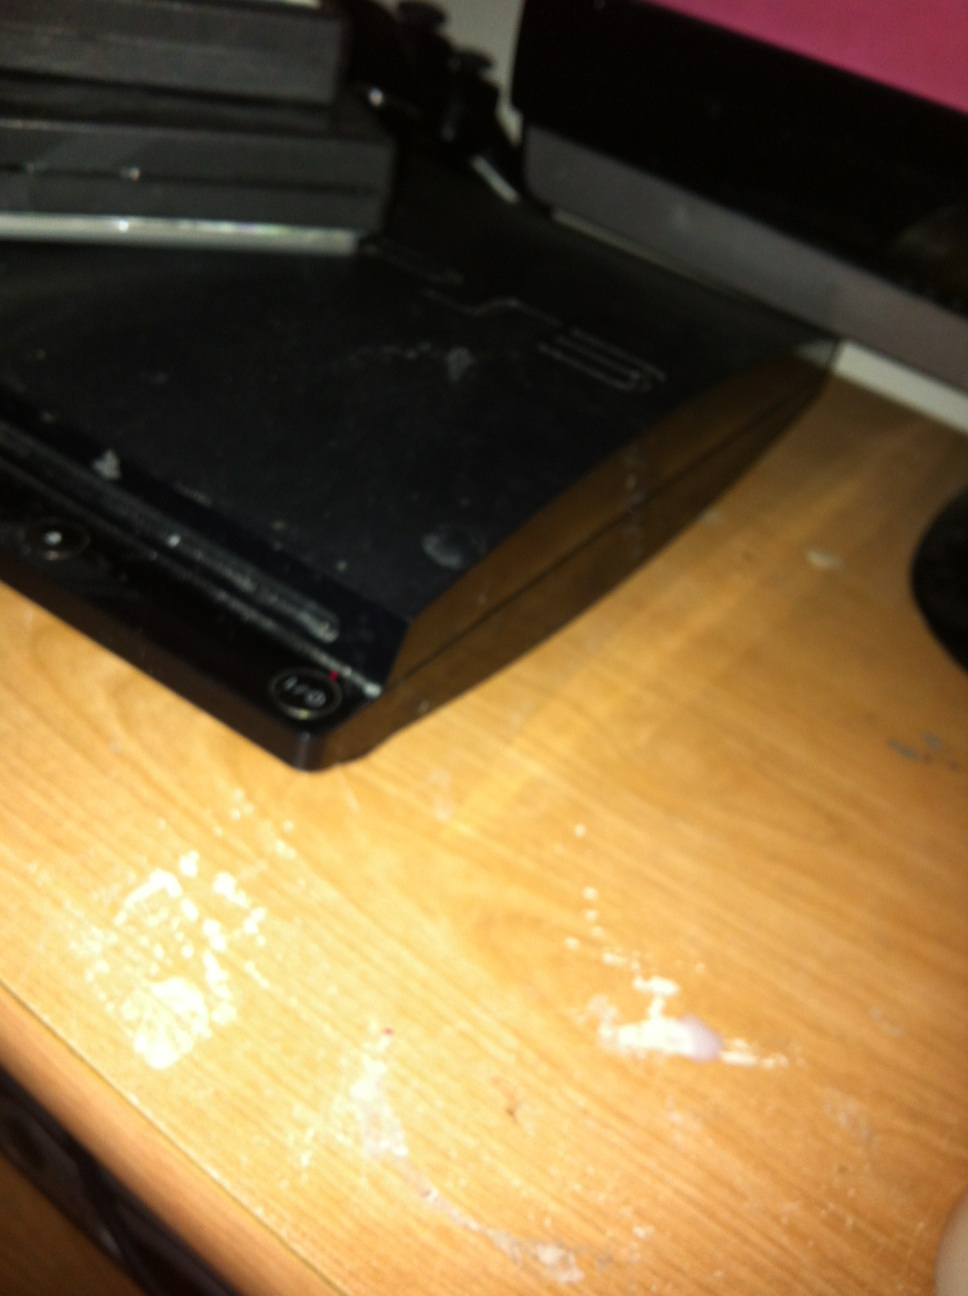What types of games can you play on the PlayStation 3? The PlayStation 3 has a vast library of games catering to all sorts of genres, including action, adventure, sports, racing, role-playing, strategy, and more. Some of the most popular titles include 'The Last of Us', 'Uncharted' series, 'God of War III', 'Grand Theft Auto V', 'Metal Gear Solid 4: Guns of the Patriots', 'LittleBigPlanet', and 'Gran Turismo 5'. The console also supported many third-party games and had backward compatibility with many PlayStation 2 and PlayStation games, allowing players to enjoy a wide range of classic titles. How did the PlayStation 3 contribute to the evolution of video gaming? The PlayStation 3 significantly contributed to the evolution of video gaming in several ways. Firstly, its powerful hardware and the Cell microprocessor allowed for unprecedented graphical detail and complex game mechanics, pushing the boundaries of what was possible in gaming. Additionally, the introduction of Blu-ray discs provided greater storage capacity for games, leading to more extensive and immersive game worlds. The PlayStation Network was also groundbreaking, creating a robust online gaming community and offering digital distribution of games and media. This evolution in online services set a new standard for connectivity and digital consumption in gaming. Furthermore, the PS3 supported motion control through the PlayStation Move, adding a new dimension to gaming interactivity. Overall, the PS3's innovations helped shape the modern gaming landscape. 